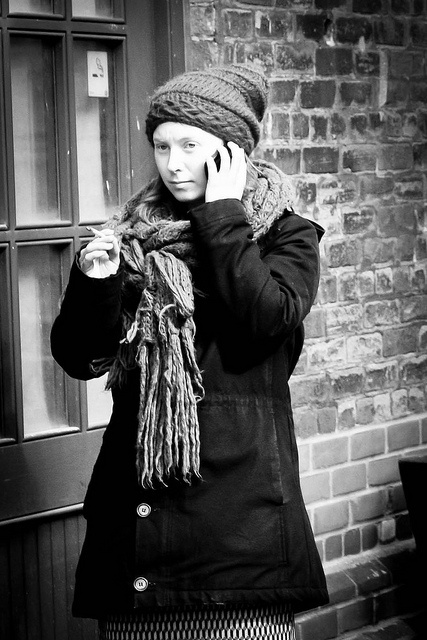Describe the objects in this image and their specific colors. I can see people in black, lightgray, gray, and darkgray tones and cell phone in black, darkgray, gray, and lightgray tones in this image. 